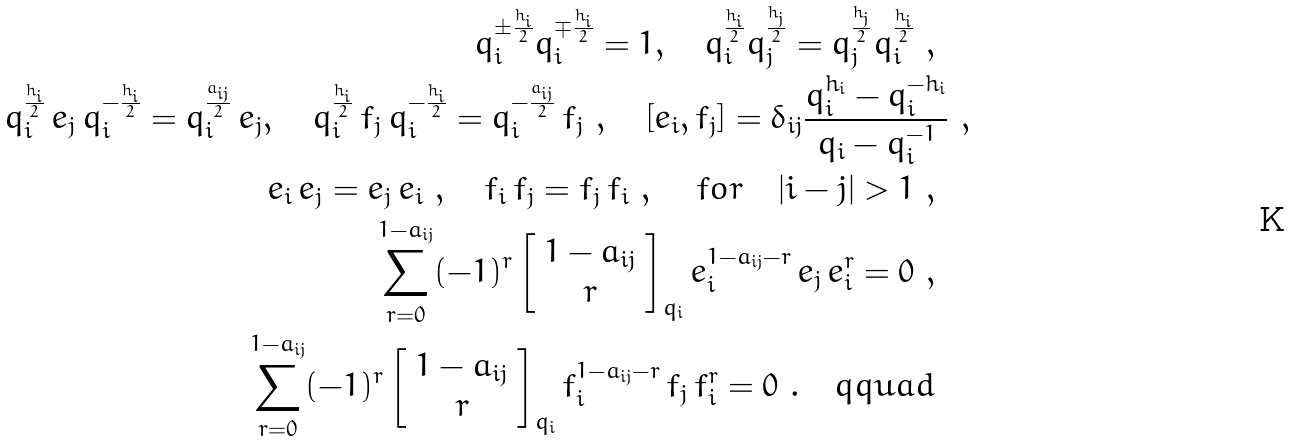Convert formula to latex. <formula><loc_0><loc_0><loc_500><loc_500>q _ { i } ^ { \pm \frac { h _ { i } } { 2 } } q _ { i } ^ { \mp \frac { h _ { i } } { 2 } } = 1 , \quad q _ { i } ^ { \frac { h _ { i } } { 2 } } q _ { j } ^ { \frac { h _ { j } } { 2 } } = q _ { j } ^ { \frac { h _ { j } } { 2 } } q _ { i } ^ { \frac { h _ { i } } { 2 } } \ , \quad \\ q _ { i } ^ { \frac { h _ { i } } { 2 } } \, e _ { j } \, q _ { i } ^ { - \frac { h _ { i } } { 2 } } = q _ { i } ^ { \frac { a _ { i j } } { 2 } } \, e _ { j } , \quad q _ { i } ^ { \frac { h _ { i } } { 2 } } \, f _ { j } \, q _ { i } ^ { - \frac { h _ { i } } { 2 } } = q _ { i } ^ { - \frac { a _ { i j } } { 2 } } \, f _ { j } \ , \quad \null [ e _ { i } , f _ { j } ] = \delta _ { i j } \frac { q _ { i } ^ { h _ { i } } - q _ { i } ^ { - h _ { i } } } { q _ { i } - q _ { i } ^ { - 1 } } \ , \\ e _ { i } \, e _ { j } = e _ { j } \, e _ { i } \ , \quad f _ { i } \, f _ { j } = f _ { j } \, f _ { i } \ , \, \quad f o r \quad | i - j | > 1 \ , \quad \\ \sum _ { r = 0 } ^ { 1 - a _ { i j } } ( - 1 ) ^ { r } \left [ \begin{array} { c } 1 - a _ { i j } \\ r \end{array} \right ] _ { q _ { i } } e _ { i } ^ { 1 - a _ { i j } - r } \, e _ { j } \, e _ { i } ^ { r } = 0 \ , \quad \\ \sum _ { r = 0 } ^ { 1 - a _ { i j } } ( - 1 ) ^ { r } \left [ \begin{array} { c } 1 - a _ { i j } \\ r \end{array} \right ] _ { q _ { i } } f _ { i } ^ { 1 - a _ { i j } - r } \, f _ { j } \, f _ { i } ^ { r } = 0 \ . \quad q q u a d \quad</formula> 